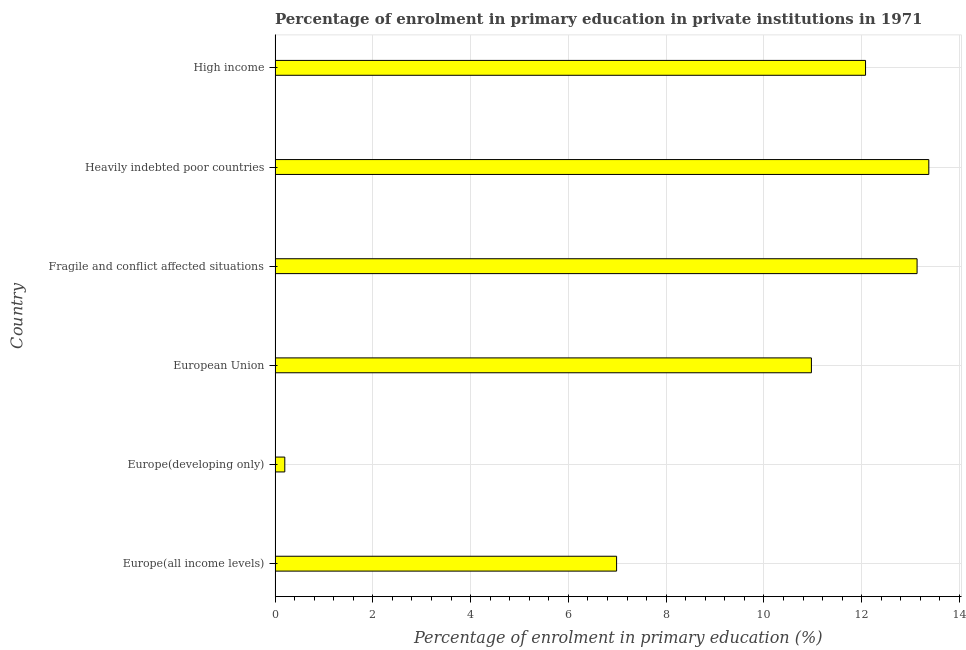Does the graph contain grids?
Your response must be concise. Yes. What is the title of the graph?
Offer a terse response. Percentage of enrolment in primary education in private institutions in 1971. What is the label or title of the X-axis?
Your response must be concise. Percentage of enrolment in primary education (%). What is the enrolment percentage in primary education in Heavily indebted poor countries?
Provide a succinct answer. 13.37. Across all countries, what is the maximum enrolment percentage in primary education?
Offer a very short reply. 13.37. Across all countries, what is the minimum enrolment percentage in primary education?
Your response must be concise. 0.2. In which country was the enrolment percentage in primary education maximum?
Your response must be concise. Heavily indebted poor countries. In which country was the enrolment percentage in primary education minimum?
Keep it short and to the point. Europe(developing only). What is the sum of the enrolment percentage in primary education?
Give a very brief answer. 56.73. What is the difference between the enrolment percentage in primary education in Europe(all income levels) and High income?
Your response must be concise. -5.09. What is the average enrolment percentage in primary education per country?
Your answer should be very brief. 9.46. What is the median enrolment percentage in primary education?
Ensure brevity in your answer.  11.52. What is the ratio of the enrolment percentage in primary education in Europe(all income levels) to that in Heavily indebted poor countries?
Make the answer very short. 0.52. Is the enrolment percentage in primary education in Europe(all income levels) less than that in High income?
Give a very brief answer. Yes. Is the difference between the enrolment percentage in primary education in Heavily indebted poor countries and High income greater than the difference between any two countries?
Your response must be concise. No. What is the difference between the highest and the second highest enrolment percentage in primary education?
Keep it short and to the point. 0.24. Is the sum of the enrolment percentage in primary education in Europe(developing only) and European Union greater than the maximum enrolment percentage in primary education across all countries?
Your response must be concise. No. What is the difference between the highest and the lowest enrolment percentage in primary education?
Keep it short and to the point. 13.17. In how many countries, is the enrolment percentage in primary education greater than the average enrolment percentage in primary education taken over all countries?
Keep it short and to the point. 4. How many bars are there?
Ensure brevity in your answer.  6. Are all the bars in the graph horizontal?
Offer a very short reply. Yes. How many countries are there in the graph?
Your answer should be compact. 6. What is the Percentage of enrolment in primary education (%) of Europe(all income levels)?
Offer a terse response. 6.99. What is the Percentage of enrolment in primary education (%) in Europe(developing only)?
Make the answer very short. 0.2. What is the Percentage of enrolment in primary education (%) of European Union?
Your answer should be very brief. 10.97. What is the Percentage of enrolment in primary education (%) of Fragile and conflict affected situations?
Give a very brief answer. 13.13. What is the Percentage of enrolment in primary education (%) of Heavily indebted poor countries?
Make the answer very short. 13.37. What is the Percentage of enrolment in primary education (%) of High income?
Offer a terse response. 12.08. What is the difference between the Percentage of enrolment in primary education (%) in Europe(all income levels) and Europe(developing only)?
Keep it short and to the point. 6.79. What is the difference between the Percentage of enrolment in primary education (%) in Europe(all income levels) and European Union?
Your response must be concise. -3.98. What is the difference between the Percentage of enrolment in primary education (%) in Europe(all income levels) and Fragile and conflict affected situations?
Make the answer very short. -6.15. What is the difference between the Percentage of enrolment in primary education (%) in Europe(all income levels) and Heavily indebted poor countries?
Your response must be concise. -6.39. What is the difference between the Percentage of enrolment in primary education (%) in Europe(all income levels) and High income?
Your answer should be compact. -5.09. What is the difference between the Percentage of enrolment in primary education (%) in Europe(developing only) and European Union?
Make the answer very short. -10.77. What is the difference between the Percentage of enrolment in primary education (%) in Europe(developing only) and Fragile and conflict affected situations?
Give a very brief answer. -12.93. What is the difference between the Percentage of enrolment in primary education (%) in Europe(developing only) and Heavily indebted poor countries?
Provide a short and direct response. -13.17. What is the difference between the Percentage of enrolment in primary education (%) in Europe(developing only) and High income?
Your response must be concise. -11.88. What is the difference between the Percentage of enrolment in primary education (%) in European Union and Fragile and conflict affected situations?
Your answer should be compact. -2.16. What is the difference between the Percentage of enrolment in primary education (%) in European Union and Heavily indebted poor countries?
Give a very brief answer. -2.4. What is the difference between the Percentage of enrolment in primary education (%) in European Union and High income?
Your answer should be compact. -1.11. What is the difference between the Percentage of enrolment in primary education (%) in Fragile and conflict affected situations and Heavily indebted poor countries?
Provide a succinct answer. -0.24. What is the difference between the Percentage of enrolment in primary education (%) in Fragile and conflict affected situations and High income?
Give a very brief answer. 1.05. What is the difference between the Percentage of enrolment in primary education (%) in Heavily indebted poor countries and High income?
Keep it short and to the point. 1.29. What is the ratio of the Percentage of enrolment in primary education (%) in Europe(all income levels) to that in Europe(developing only)?
Keep it short and to the point. 35.16. What is the ratio of the Percentage of enrolment in primary education (%) in Europe(all income levels) to that in European Union?
Offer a very short reply. 0.64. What is the ratio of the Percentage of enrolment in primary education (%) in Europe(all income levels) to that in Fragile and conflict affected situations?
Offer a very short reply. 0.53. What is the ratio of the Percentage of enrolment in primary education (%) in Europe(all income levels) to that in Heavily indebted poor countries?
Ensure brevity in your answer.  0.52. What is the ratio of the Percentage of enrolment in primary education (%) in Europe(all income levels) to that in High income?
Offer a very short reply. 0.58. What is the ratio of the Percentage of enrolment in primary education (%) in Europe(developing only) to that in European Union?
Offer a terse response. 0.02. What is the ratio of the Percentage of enrolment in primary education (%) in Europe(developing only) to that in Fragile and conflict affected situations?
Make the answer very short. 0.01. What is the ratio of the Percentage of enrolment in primary education (%) in Europe(developing only) to that in Heavily indebted poor countries?
Offer a terse response. 0.01. What is the ratio of the Percentage of enrolment in primary education (%) in Europe(developing only) to that in High income?
Make the answer very short. 0.02. What is the ratio of the Percentage of enrolment in primary education (%) in European Union to that in Fragile and conflict affected situations?
Your answer should be compact. 0.83. What is the ratio of the Percentage of enrolment in primary education (%) in European Union to that in Heavily indebted poor countries?
Your answer should be compact. 0.82. What is the ratio of the Percentage of enrolment in primary education (%) in European Union to that in High income?
Offer a terse response. 0.91. What is the ratio of the Percentage of enrolment in primary education (%) in Fragile and conflict affected situations to that in Heavily indebted poor countries?
Keep it short and to the point. 0.98. What is the ratio of the Percentage of enrolment in primary education (%) in Fragile and conflict affected situations to that in High income?
Give a very brief answer. 1.09. What is the ratio of the Percentage of enrolment in primary education (%) in Heavily indebted poor countries to that in High income?
Offer a terse response. 1.11. 